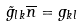Convert formula to latex. <formula><loc_0><loc_0><loc_500><loc_500>\tilde { g } _ { l k } \overline { n } = g _ { k l }</formula> 